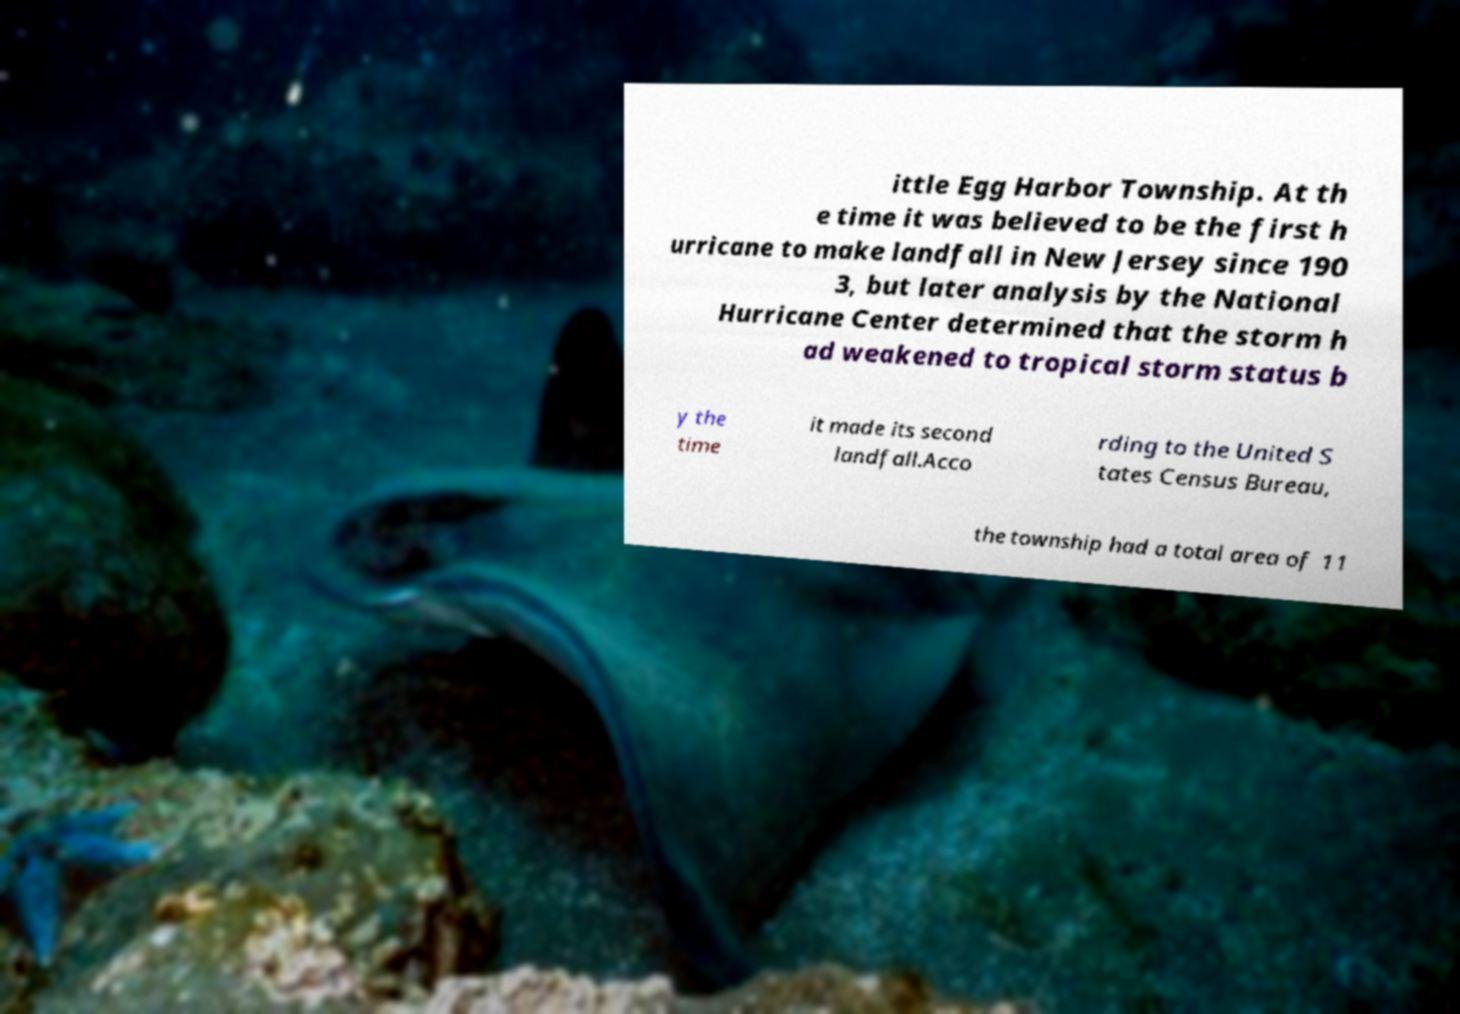Can you accurately transcribe the text from the provided image for me? ittle Egg Harbor Township. At th e time it was believed to be the first h urricane to make landfall in New Jersey since 190 3, but later analysis by the National Hurricane Center determined that the storm h ad weakened to tropical storm status b y the time it made its second landfall.Acco rding to the United S tates Census Bureau, the township had a total area of 11 